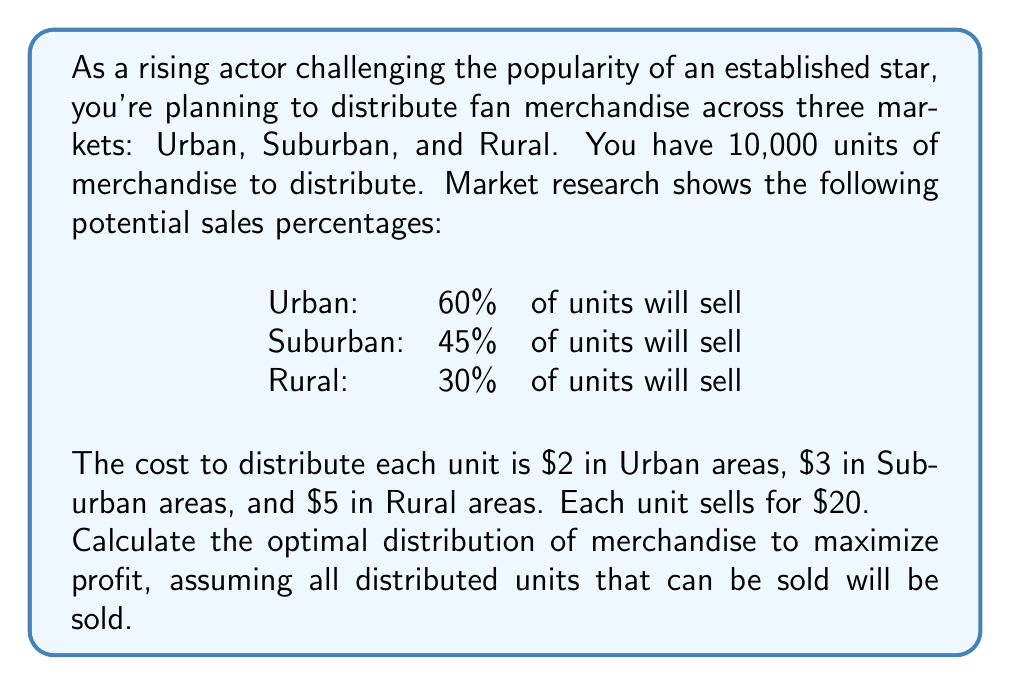Show me your answer to this math problem. Let's approach this step-by-step:

1) Define variables:
   Let $x$, $y$, and $z$ be the number of units distributed to Urban, Suburban, and Rural areas respectively.

2) Set up the objective function:
   Profit = Revenue - Cost
   $P = 20(0.6x + 0.45y + 0.3z) - (2x + 3y + 5z)$
   $P = 10x + 6y + z$

3) Constraints:
   Total units: $x + y + z = 10000$
   Non-negativity: $x, y, z \geq 0$

4) This is a linear programming problem. The optimal solution will be at one of the extreme points of the feasible region.

5) Given the coefficients in the objective function (10, 6, 1), it's clear that to maximize profit, we should prioritize Urban, then Suburban, then Rural.

6) Optimal distribution:
   Urban (x): 10000 units
   Suburban (y): 0 units
   Rural (z): 0 units

7) Calculate maximum profit:
   $P = 10(10000) + 6(0) + 1(0) = 100000$

Therefore, the optimal distribution is to allocate all 10,000 units to the Urban market, resulting in a maximum profit of $100,000.
Answer: Optimal distribution: Urban: 10,000 units, Suburban: 0 units, Rural: 0 units. Maximum profit: $100,000. 